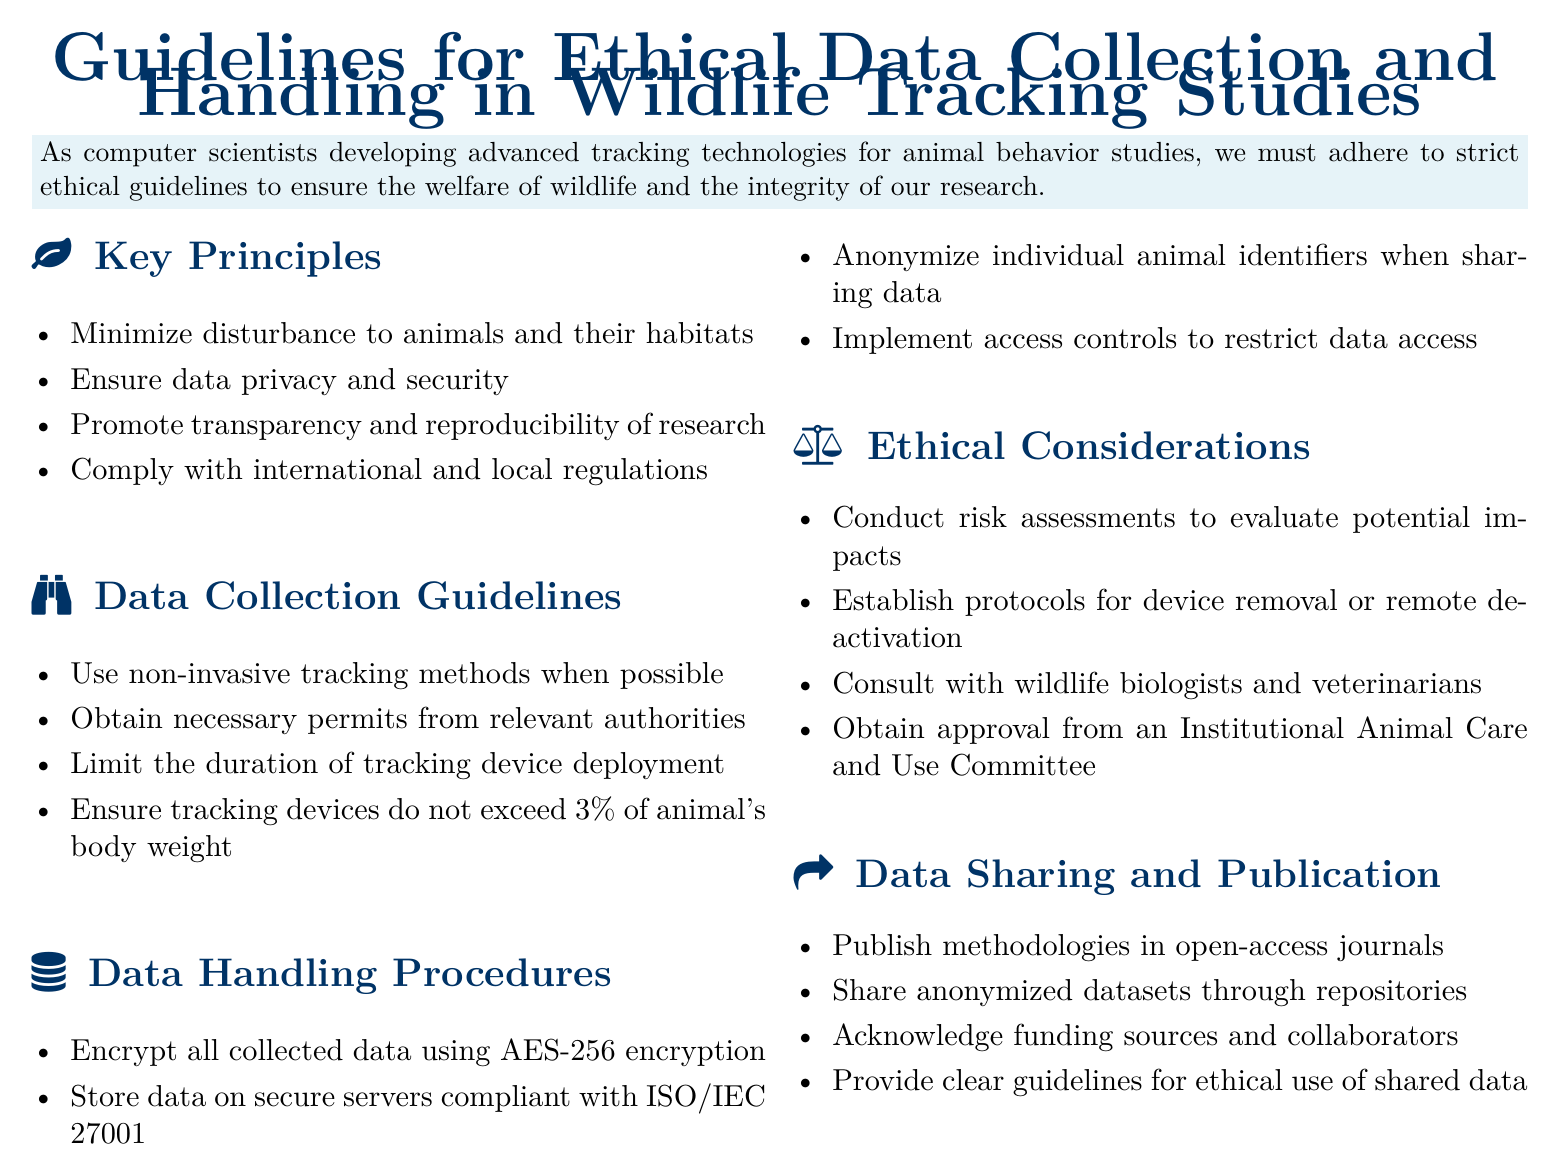what is the maximum weight percentage for tracking devices? The document states that tracking devices should not exceed 3% of the animal's body weight.
Answer: 3% what should researchers obtain from relevant authorities before data collection? The guidelines indicate that necessary permits must be obtained before tracking animals.
Answer: permits which encryption standard is recommended for data collected in wildlife tracking studies? The document specifies that AES-256 encryption should be used to encrypt all collected data.
Answer: AES-256 what is emphasized for the transparency of research? The guidelines promote transparency and reproducibility of research as a key principle.
Answer: transparency and reproducibility who should be consulted for ethical considerations in wildlife tracking studies? The document advises that researchers should consult with wildlife biologists and veterinarians.
Answer: wildlife biologists and veterinarians in which type of journals should methodologies be published according to the guidelines? The guidelines recommend publishing methodologies in open-access journals.
Answer: open-access journals what must researchers implement to control data access? The document states that access controls must be implemented to restrict data access.
Answer: access controls how should individual animal identifiers be treated when sharing data? The guidelines state that individual animal identifiers should be anonymized when sharing data.
Answer: anonymized what ethical approval is necessary before conducting wildlife tracking studies? The document mentions that approval from an Institutional Animal Care and Use Committee is required.
Answer: Institutional Animal Care and Use Committee 